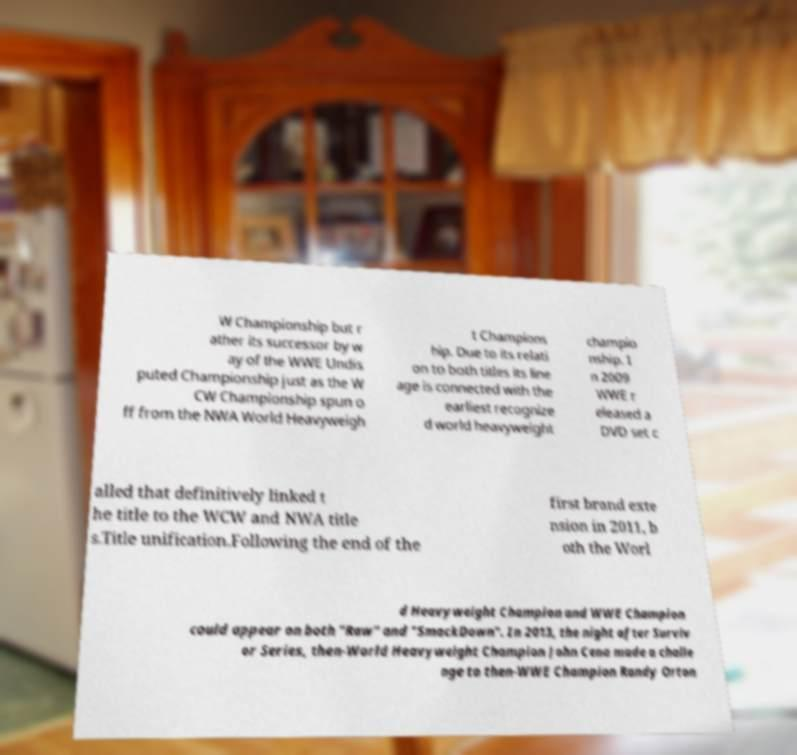Could you assist in decoding the text presented in this image and type it out clearly? W Championship but r ather its successor by w ay of the WWE Undis puted Championship just as the W CW Championship spun o ff from the NWA World Heavyweigh t Champions hip. Due to its relati on to both titles its line age is connected with the earliest recognize d world heavyweight champio nship. I n 2009 WWE r eleased a DVD set c alled that definitively linked t he title to the WCW and NWA title s.Title unification.Following the end of the first brand exte nsion in 2011, b oth the Worl d Heavyweight Champion and WWE Champion could appear on both "Raw" and "SmackDown". In 2013, the night after Surviv or Series, then-World Heavyweight Champion John Cena made a challe nge to then-WWE Champion Randy Orton 